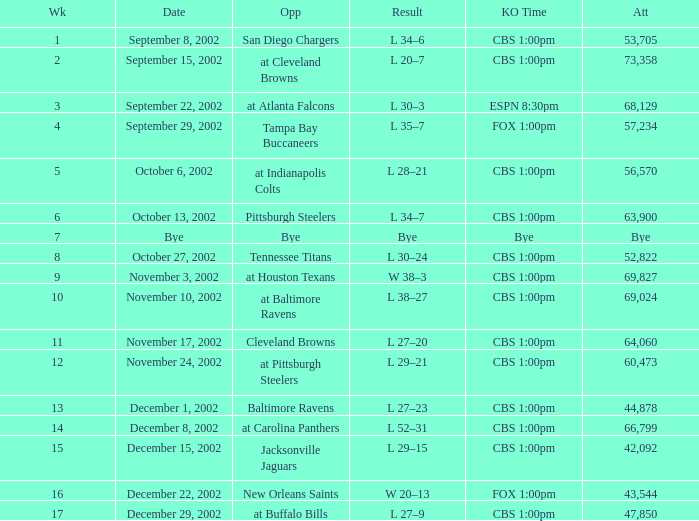What is the kickoff time on November 10, 2002? CBS 1:00pm. 